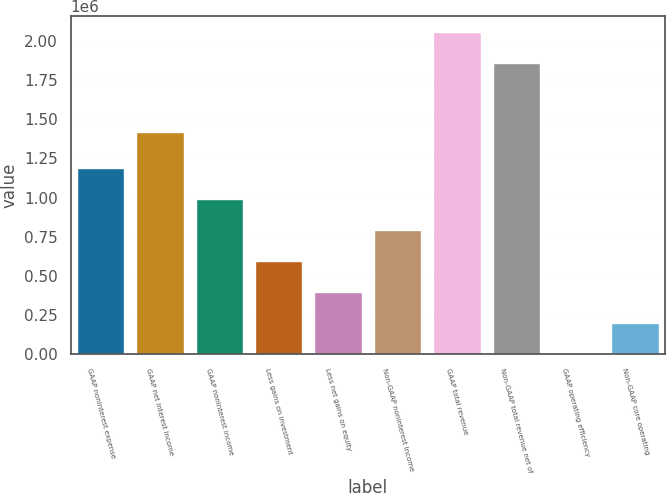Convert chart. <chart><loc_0><loc_0><loc_500><loc_500><bar_chart><fcel>GAAP noninterest expense<fcel>GAAP net interest income<fcel>GAAP noninterest income<fcel>Less gains on investment<fcel>Less net gains on equity<fcel>Non-GAAP noninterest income<fcel>GAAP total revenue<fcel>Non-GAAP total revenue net of<fcel>GAAP operating efficiency<fcel>Non-GAAP core operating<nl><fcel>1.18658e+06<fcel>1.42037e+06<fcel>988826<fcel>593316<fcel>395561<fcel>791071<fcel>2.0562e+06<fcel>1.85844e+06<fcel>51.11<fcel>197806<nl></chart> 